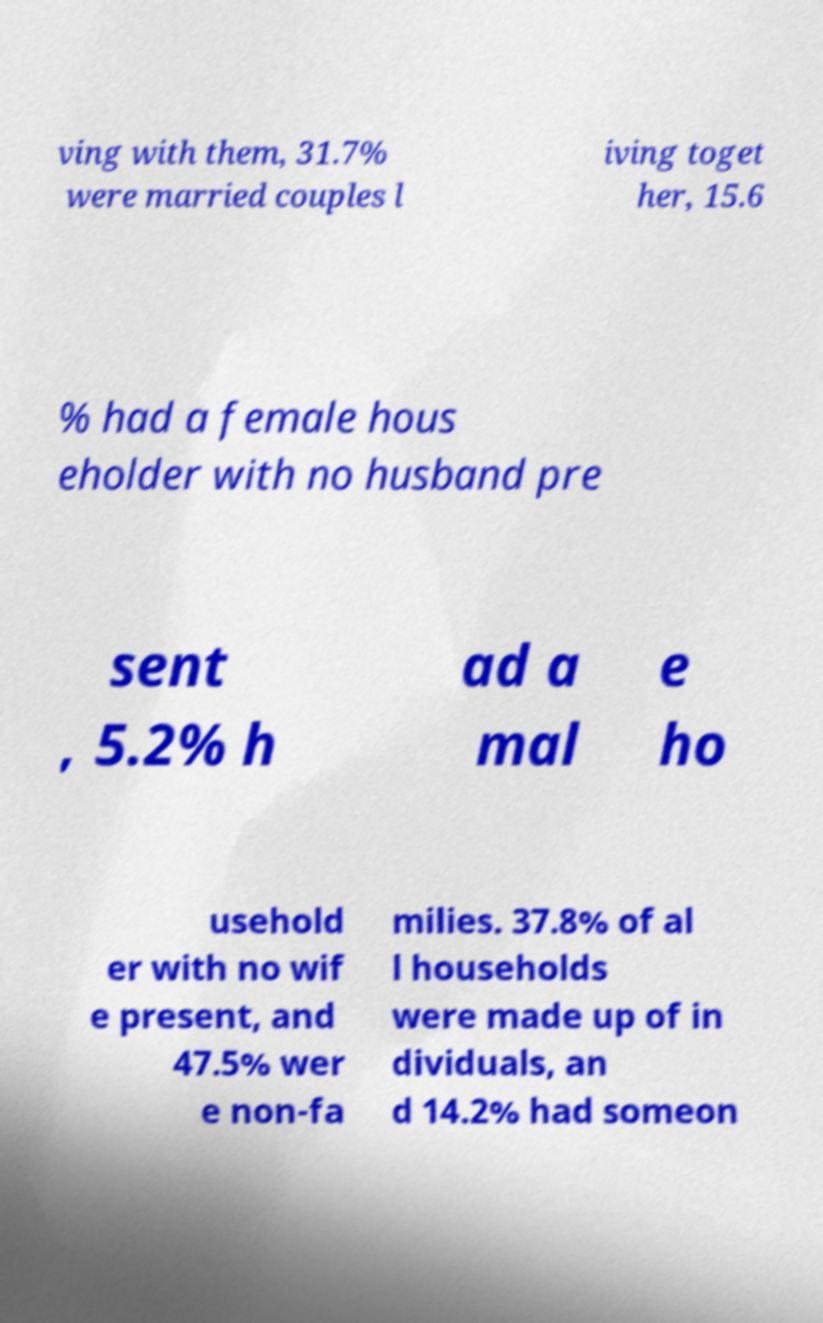Could you extract and type out the text from this image? ving with them, 31.7% were married couples l iving toget her, 15.6 % had a female hous eholder with no husband pre sent , 5.2% h ad a mal e ho usehold er with no wif e present, and 47.5% wer e non-fa milies. 37.8% of al l households were made up of in dividuals, an d 14.2% had someon 